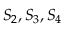<formula> <loc_0><loc_0><loc_500><loc_500>S _ { 2 } , S _ { 3 } , S _ { 4 }</formula> 